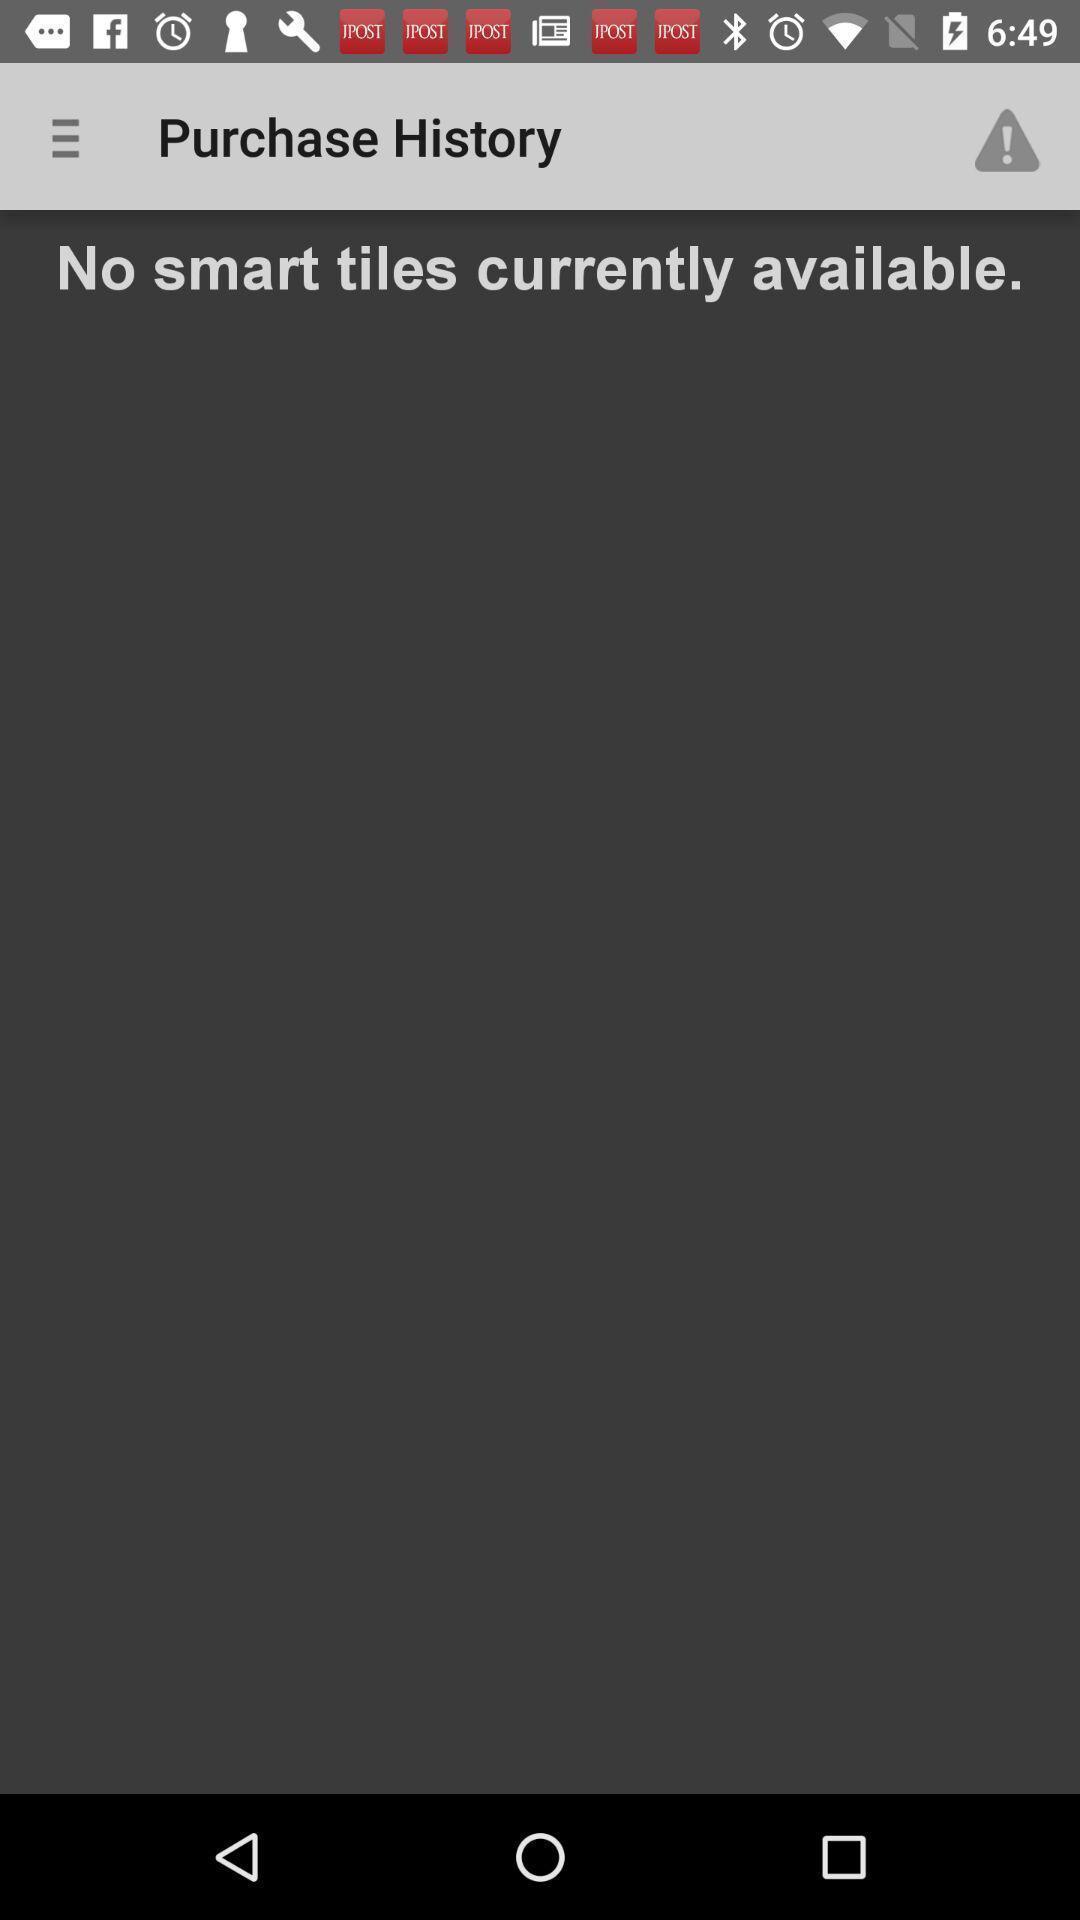Describe the key features of this screenshot. Screen showing purchase history page of a shopping app. 